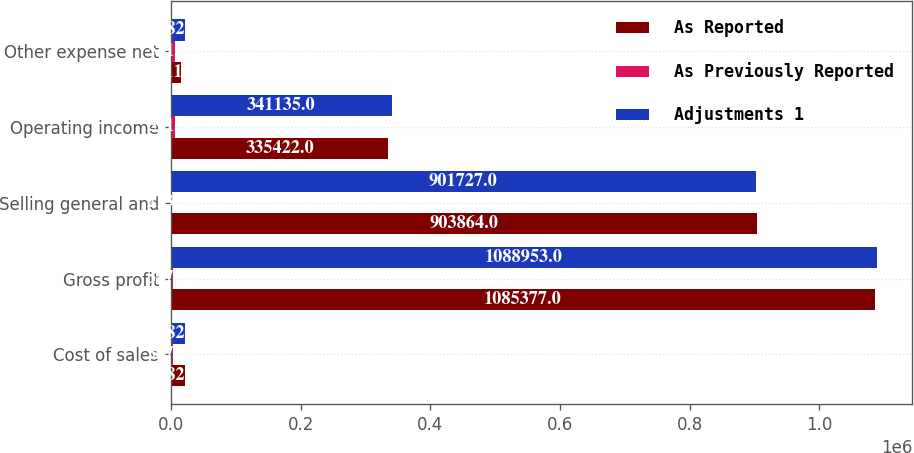<chart> <loc_0><loc_0><loc_500><loc_500><stacked_bar_chart><ecel><fcel>Cost of sales<fcel>Gross profit<fcel>Selling general and<fcel>Operating income<fcel>Other expense net<nl><fcel>As Reported<fcel>21827<fcel>1.08538e+06<fcel>903864<fcel>335422<fcel>16114<nl><fcel>As Previously Reported<fcel>3576<fcel>3576<fcel>2137<fcel>5713<fcel>5713<nl><fcel>Adjustments 1<fcel>21827<fcel>1.08895e+06<fcel>901727<fcel>341135<fcel>21827<nl></chart> 